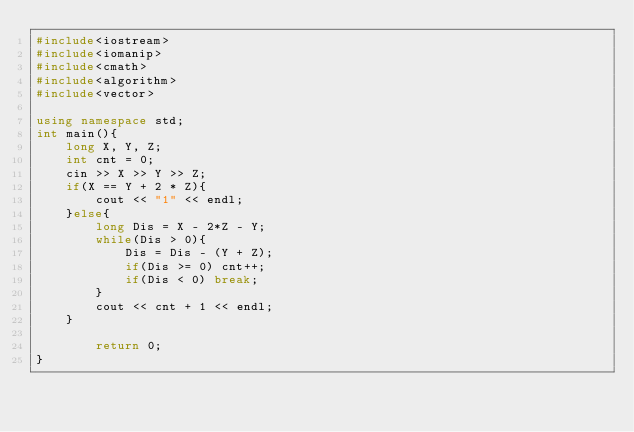Convert code to text. <code><loc_0><loc_0><loc_500><loc_500><_C++_>#include<iostream>
#include<iomanip>
#include<cmath>
#include<algorithm>
#include<vector>

using namespace std;
int main(){
    long X, Y, Z;
    int cnt = 0;
    cin >> X >> Y >> Z;
    if(X == Y + 2 * Z){
        cout << "1" << endl;
    }else{
        long Dis = X - 2*Z - Y;
        while(Dis > 0){
            Dis = Dis - (Y + Z);
            if(Dis >= 0) cnt++;
            if(Dis < 0) break;
        }
        cout << cnt + 1 << endl;
    }
    
        return 0;
}</code> 